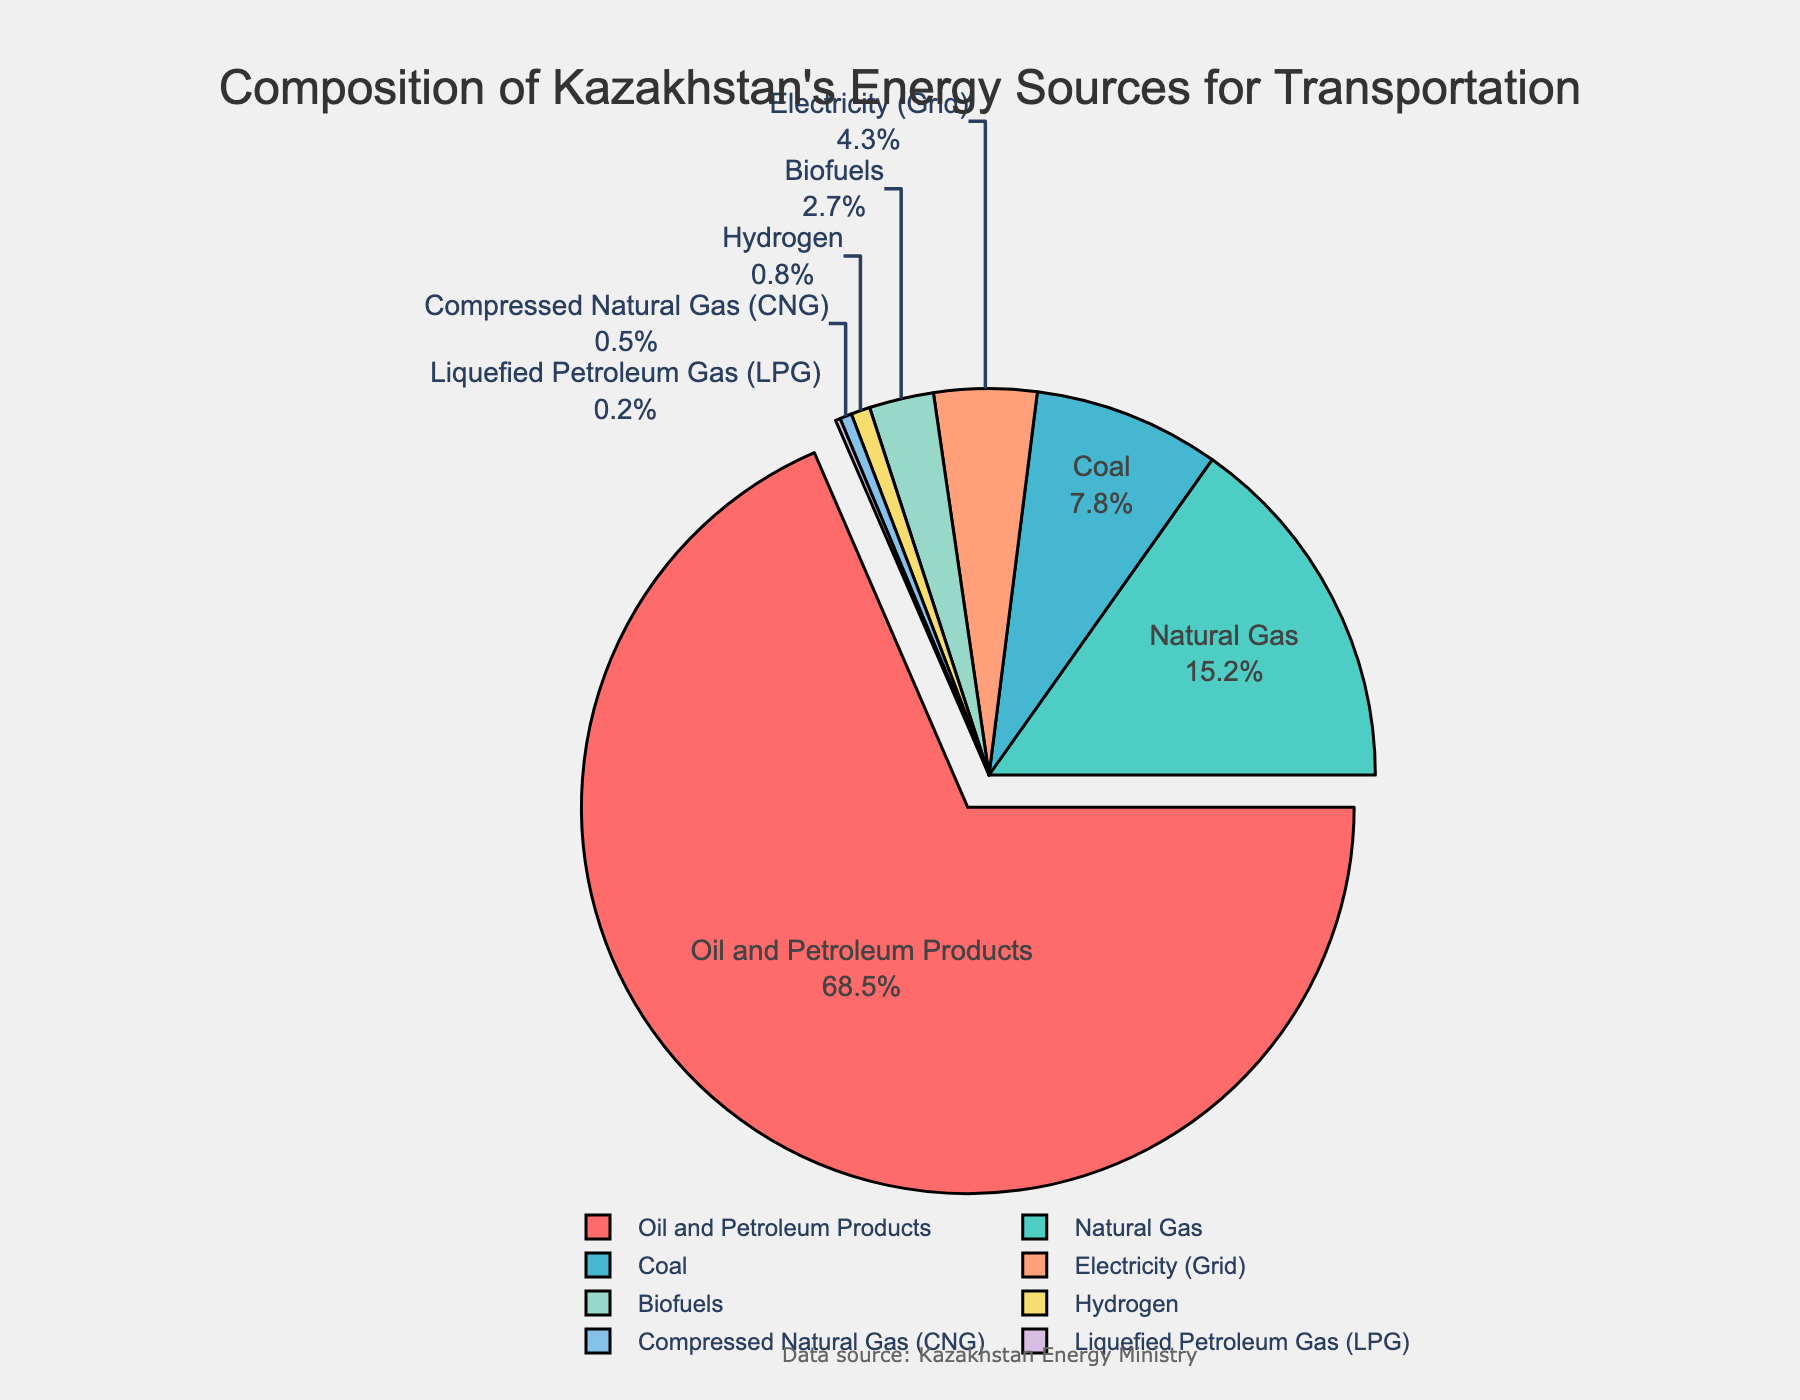Which energy source has the highest percentage? The segment with the highest percentage is labeled as "Oil and Petroleum Products" with a percentage of 68.5%.
Answer: Oil and Petroleum Products What is the combined percentage of Natural Gas and Biofuels? The percentage for Natural Gas is 15.2% and for Biofuels is 2.7%. Adding these, 15.2% + 2.7% = 17.9%.
Answer: 17.9% How does the percentage of Coal compare to Electricity (Grid)? The Coal segment is labeled with 7.8% and the Electricity (Grid) segment is labeled with 4.3%. Thus, Coal has a higher percentage.
Answer: Coal has a higher percentage Which energy sources have a percentage below 1%? The segments labeled with below 1% are "Hydrogen" (0.8%), "Compressed Natural Gas (CNG)" (0.5%), and "Liquefied Petroleum Gas (LPG)" (0.2%).
Answer: Hydrogen, Compressed Natural Gas (CNG), Liquefied Petroleum Gas (LPG) What is the visual difference between the Oil and Petroleum Products segment and other segments? The Oil and Petroleum Products segment is visually pulled out from the pie chart to highlight it as the largest segment. Additionally, it has the largest area and is colored in red.
Answer: Pulled out and largest area Which three energy sources together provide close to 100% of the energy? The top three percentage segments are: Oil and Petroleum Products (68.5%), Natural Gas (15.2%), and Coal (7.8%). Adding these, 68.5% + 15.2% + 7.8% = 91.5%.
Answer: Oil and Petroleum Products, Natural Gas, and Coal What is the difference in percentage between the largest segment and the smallest segment? The largest segment is Oil and Petroleum Products with 68.5%, and the smallest segment is Liquefied Petroleum Gas (LPG) with 0.2%. The difference is 68.5% - 0.2% = 68.3%.
Answer: 68.3% Which energy sources are represented by the green and purple colors? The green segment represents Natural Gas and the purple segment represents Hydrogen.
Answer: Natural Gas and Hydrogen 